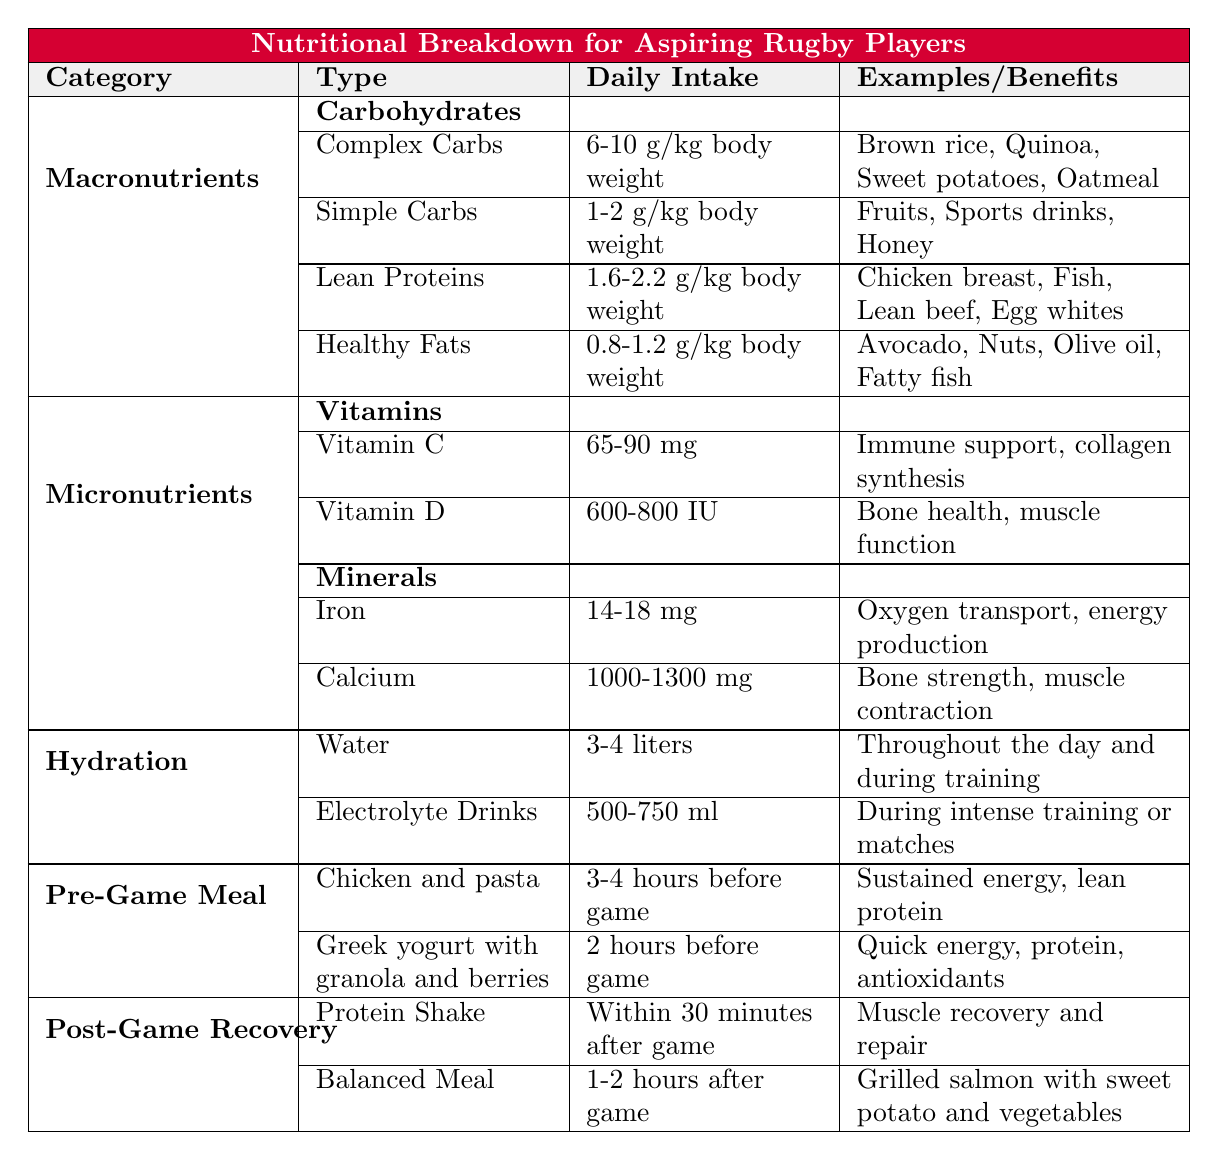What is the daily intake range for complex carbohydrates? The table provides the daily intake for complex carbohydrates as "6-10 g/kg body weight."
Answer: 6-10 g/kg body weight How many grams of simple carbohydrates should an aspiring rugby player consume daily based on body weight? The table indicates the daily intake of simple carbohydrates as "1-2 g/kg body weight."
Answer: 1-2 g/kg body weight What are two examples of lean proteins? The table lists examples of lean proteins as "Chicken breast" and "Fish."
Answer: Chicken breast, Fish Is the daily intake for Vitamin D listed as higher than 800 IU? The table specifies the daily intake for Vitamin D as "600-800 IU," which means it is not higher than 800 IU.
Answer: No Calculate the total daily intake of Iron and Calcium in mg. The table lists Iron as "14-18 mg" and Calcium as "1000-1300 mg." To find the total, we can take the maximum values: 18 + 1300 = 1318 mg.
Answer: 1318 mg What is the combined daily intake range for lean and plant-based proteins? Lean proteins are "1.6-2.2 g/kg body weight" and plant-based proteins are "0.5-0.8 g/kg body weight." To find the combined range, we add the lower limits: 1.6 + 0.5 = 2.1 g/kg and the upper limits: 2.2 + 0.8 = 3.0 g/kg. Therefore, the total range is "2.1-3.0 g/kg body weight."
Answer: 2.1-3.0 g/kg body weight Which hydration recommendation has a higher daily intake, water or electrolyte drinks? The table states that the daily intake for water is "3-4 liters," while for electrolyte drinks it is "500-750 ml." Since 3-4 liters is equivalent to 3000-4000 ml, it is evident that water has a higher intake recommendation.
Answer: Water What are the benefits of a post-game protein shake? The table states that a post-game protein shake benefits "muscle recovery and repair."
Answer: Muscle recovery and repair How many hours before a game should an aspiring rugby player eat the suggested meal of chicken and pasta? The table indicates that this meal should be consumed "3-4 hours before game."
Answer: 3-4 hours What are the daily intake ranges for Magnesium? The table specifies the daily intake for Magnesium as "310-420 mg."
Answer: 310-420 mg 